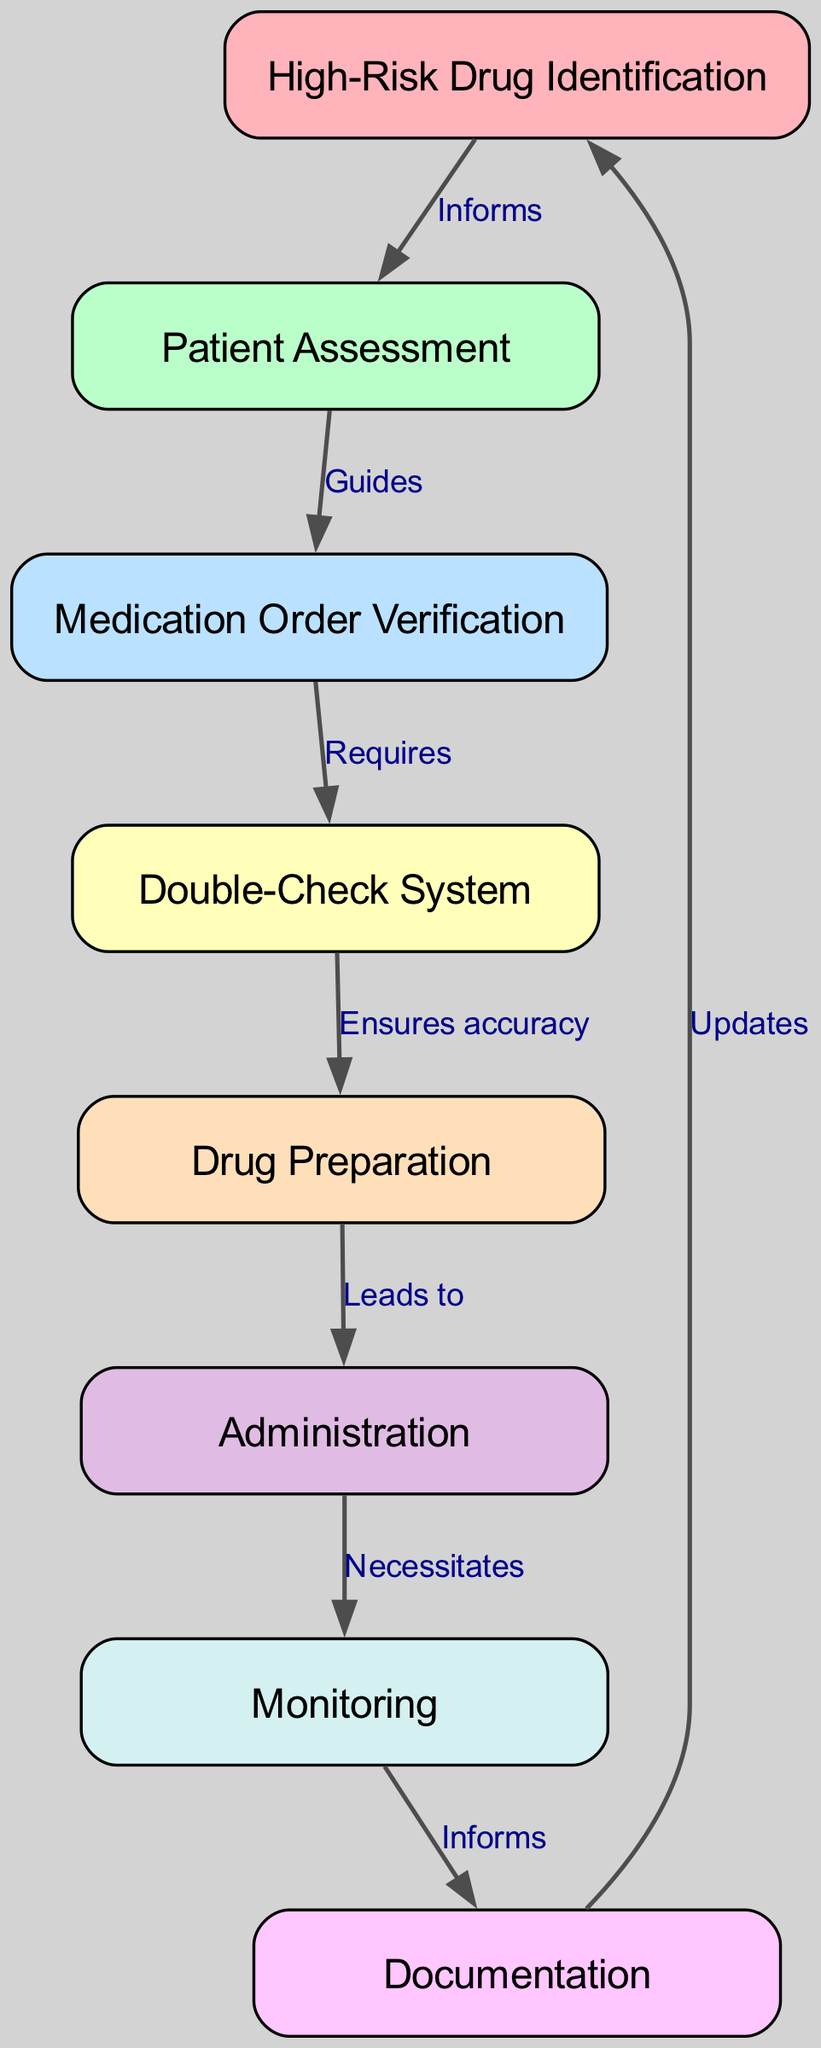What is the first node in the diagram? The first node is labeled "High-Risk Drug Identification", which can be identified as it is the node with no incoming edges.
Answer: High-Risk Drug Identification How many nodes are in the diagram? The diagram lists a total of 8 nodes as indicated by the entries in the provided data.
Answer: 8 What does "Patient Assessment" guide? The label on the edge leading from "Patient Assessment" indicates it guides the next node, which is "Medication Order Verification".
Answer: Medication Order Verification Which node is reached after "Double-Check System"? According to the diagram's flow, after "Double-Check System", the next node is "Drug Preparation". This is determined by following the directed edge.
Answer: Drug Preparation How does "Monitoring" relate to "Administration"? The edge leading from "Administration" to "Monitoring" indicates that administration necessitates monitoring, showing that monitoring follows the administration.
Answer: Necessitates What does "Documentation" update? The edge directed from "Documentation" leads back to "High-Risk Drug Identification", indicating that documentation updates this initial node related to medication administration.
Answer: High-Risk Drug Identification Which node requires "Medication Order Verification"? The edge connection shows that "Medication Order Verification" is required by the "Double-Check System", linking these two nodes in the flow of the protocol.
Answer: Double-Check System Which node is the final step before documentation? Before reaching the "Documentation" node, the flow in the diagram progresses through the "Monitoring" node. Therefore, "Monitoring" is the final step before documentation.
Answer: Monitoring What is the relationship between "Drug Preparation" and "Administration"? The flow indicates that "Drug Preparation" leads to "Administration", suggesting a direct progression in the protocol where preparation comes before actual administration.
Answer: Leads to 